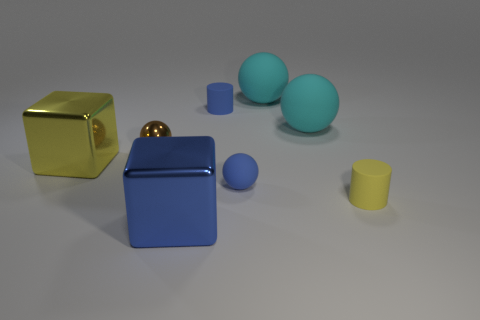Subtract all blue balls. How many balls are left? 3 Subtract all green cylinders. How many cyan spheres are left? 2 Subtract 1 spheres. How many spheres are left? 3 Add 1 tiny purple blocks. How many objects exist? 9 Subtract all blue spheres. How many spheres are left? 3 Subtract all blocks. How many objects are left? 6 Subtract all red spheres. Subtract all purple cubes. How many spheres are left? 4 Subtract 0 red balls. How many objects are left? 8 Subtract all blue objects. Subtract all small blue objects. How many objects are left? 3 Add 2 cylinders. How many cylinders are left? 4 